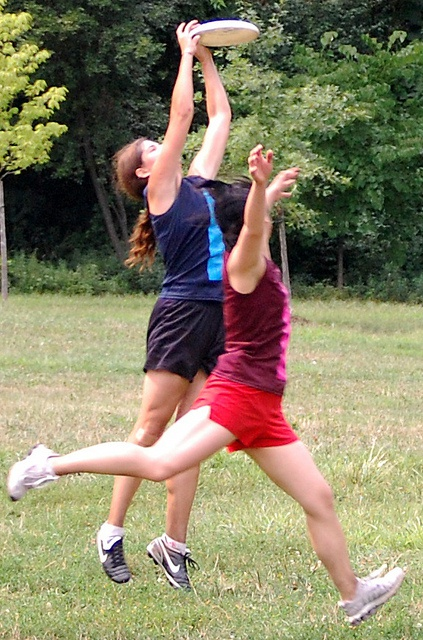Describe the objects in this image and their specific colors. I can see people in khaki, white, lightpink, maroon, and salmon tones, people in khaki, black, lightpink, white, and navy tones, and frisbee in khaki, tan, and white tones in this image. 